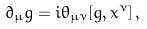Convert formula to latex. <formula><loc_0><loc_0><loc_500><loc_500>\partial _ { \mu } g = i \theta _ { \mu \nu } [ g , x ^ { \nu } ] \, ,</formula> 